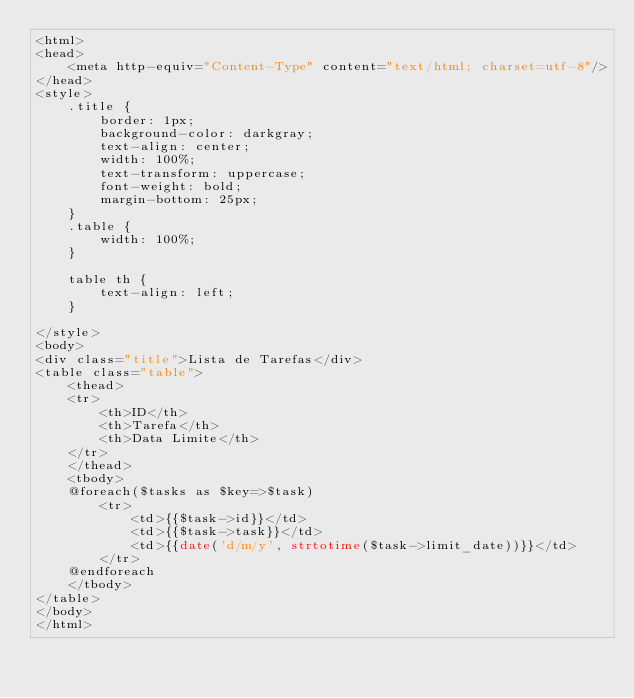Convert code to text. <code><loc_0><loc_0><loc_500><loc_500><_PHP_><html>
<head>
    <meta http-equiv="Content-Type" content="text/html; charset=utf-8"/>
</head>
<style>
    .title {
        border: 1px;
        background-color: darkgray;
        text-align: center;
        width: 100%;
        text-transform: uppercase;
        font-weight: bold;
        margin-bottom: 25px;
    }
    .table {
        width: 100%;
    }

    table th {
        text-align: left;
    }

</style>
<body>
<div class="title">Lista de Tarefas</div>
<table class="table">
    <thead>
    <tr>
        <th>ID</th>
        <th>Tarefa</th>
        <th>Data Limite</th>
    </tr>
    </thead>
    <tbody>
    @foreach($tasks as $key=>$task)
        <tr>
            <td>{{$task->id}}</td>
            <td>{{$task->task}}</td>
            <td>{{date('d/m/y', strtotime($task->limit_date))}}</td>
        </tr>
    @endforeach
    </tbody>
</table>
</body>
</html>
</code> 